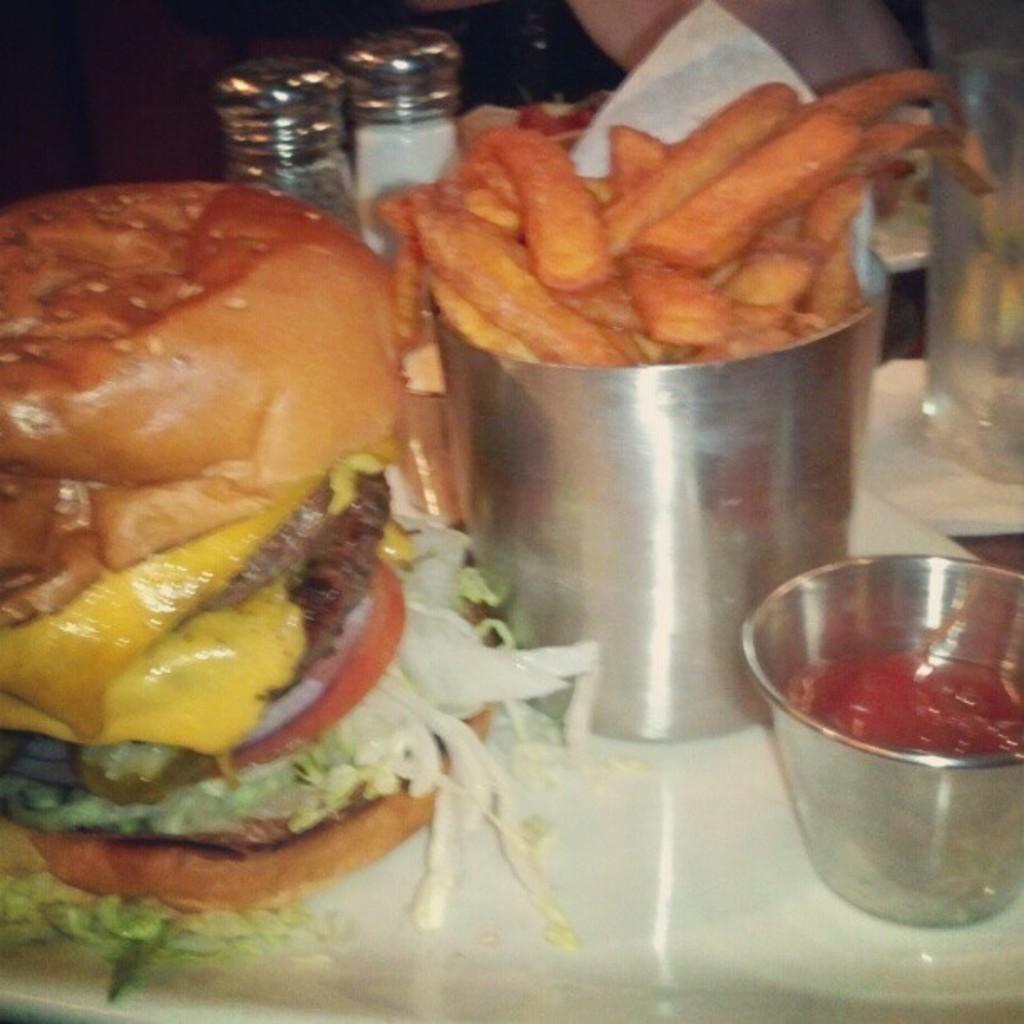In one or two sentences, can you explain what this image depicts? In this image, we can see a burger, bowls with sauce and food items, containers, glass with liquid are placed on the white surface. Top of the image, we can see the human body. 